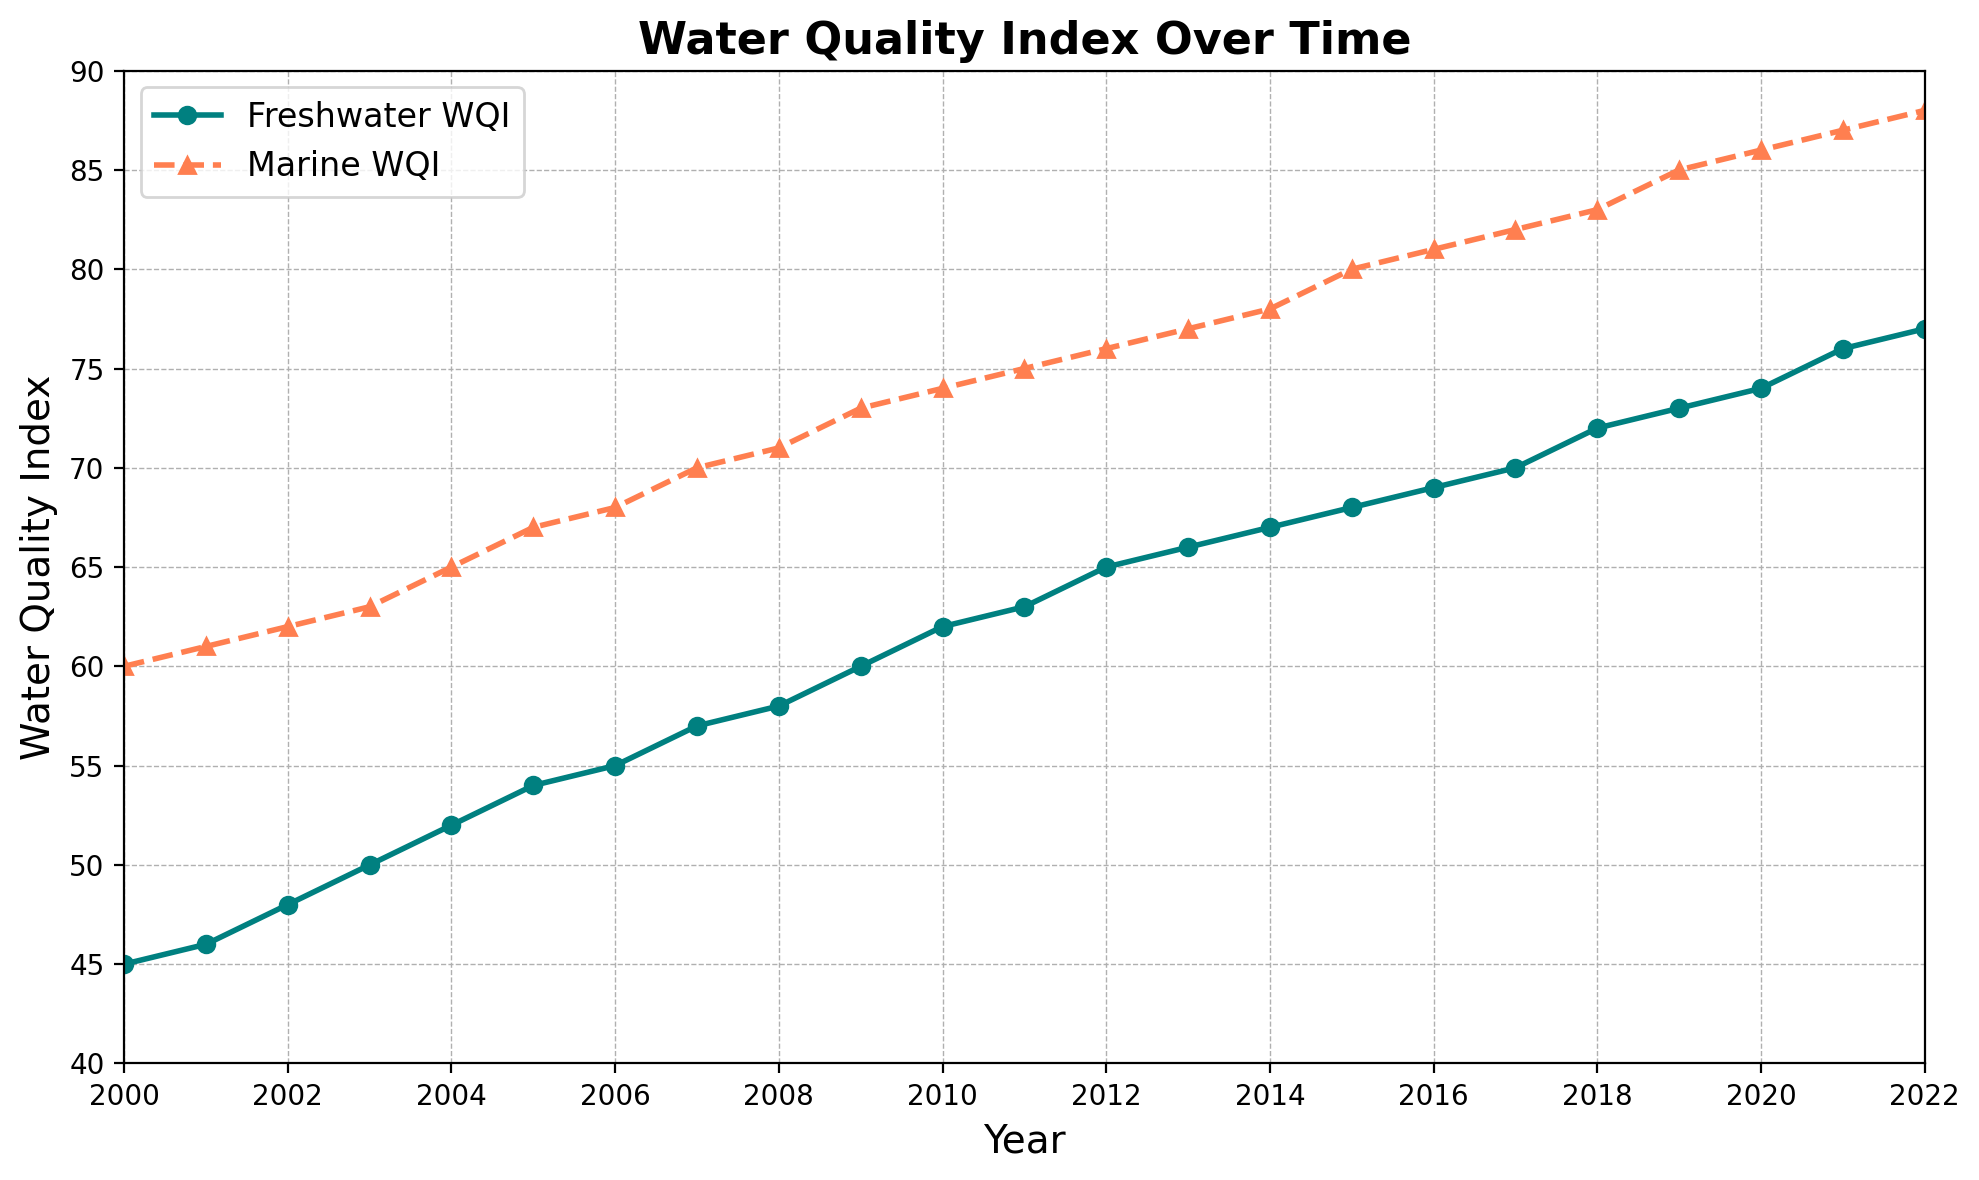What are the trends in Water Quality Index (WQI) for Freshwater and Marine sources from 2000 to 2022? The Freshwater WQI and Marine WQI both show a clear upward trend from 2000 to 2022, indicating an improvement in water quality over time. The Freshwater WQI increases from 45 to 77, while the Marine WQI increases from 60 to 88.
Answer: Both Freshwater and Marine WQI are improving over time How does the Freshwater WQI in 2010 compare to the Marine WQI in 2010? In 2010, the Freshwater WQI is at 62 and the Marine WQI is at 74. This shows that the Marine WQI is higher by 12 points compared to the Freshwater WQI in 2010.
Answer: Marine WQI is higher by 12 What is the difference in Freshwater WQI between 2000 and 2022? In 2000, the Freshwater WQI is 45, and in 2022, it is 77. The difference between these values is 77 - 45 = 32.
Answer: 32 How has the Marine WQI changed, on average, per year from 2000 to 2022? The Marine WQI increases from 60 in 2000 to 88 in 2022, over a span of 22 years. The total increase is 88 - 60 = 28. The average annual change is 28 / 22 ≈ 1.27.
Answer: Approximately 1.27 Which year shows the highest Freshwater WQI and what is its value? By looking at the upward trend, the highest point on the Freshwater WQI line is at the end of the timeline, in 2022. The value of the Freshwater WQI in 2022 is 77.
Answer: 2022 with 77 In which year did the Marine WQI first surpass 80? The Marine WQI first surpasses 80 between 2014 and 2015. By observing the graph, it is in 2015 that the Marine WQI first reaches 80.
Answer: 2015 By how much did the Freshwater WQI increase from 2005 to 2010? The Freshwater WQI in 2005 is 54, and in 2010, it is 62. The increase from 2005 to 2010 is 62 - 54 = 8.
Answer: 8 Among the years plotted, which year had the smallest gap between Freshwater and Marine WQI and what was the gap? By evaluating the relative distances between the Freshwater and Marine lines, 2022 shows the smallest gap. The Freshwater WQI is 77 and the Marine WQI is 88, so the gap is 88 - 77 = 11.
Answer: 2022 with a gap of 11 What is the average WQI for Freshwater and Marine sources over all the years? For Freshwater: Sum of WQI values / Total number of years = (45+46+48+50+52+54+55+57+58+60+62+63+65+66+67+68+69+70+72+73+74+76+77) / 23 = 1422 / 23 = 61.83. For Marine: (Sum of WQI values / Total number of years) = (60+61+62+63+65+67+68+70+71+73+74+75+76+77+78+80+81+82+83+85+86+87+88) / 23 = 1636 / 23 = 71.13.
Answer: Freshwater: 61.83, Marine: 71.13 